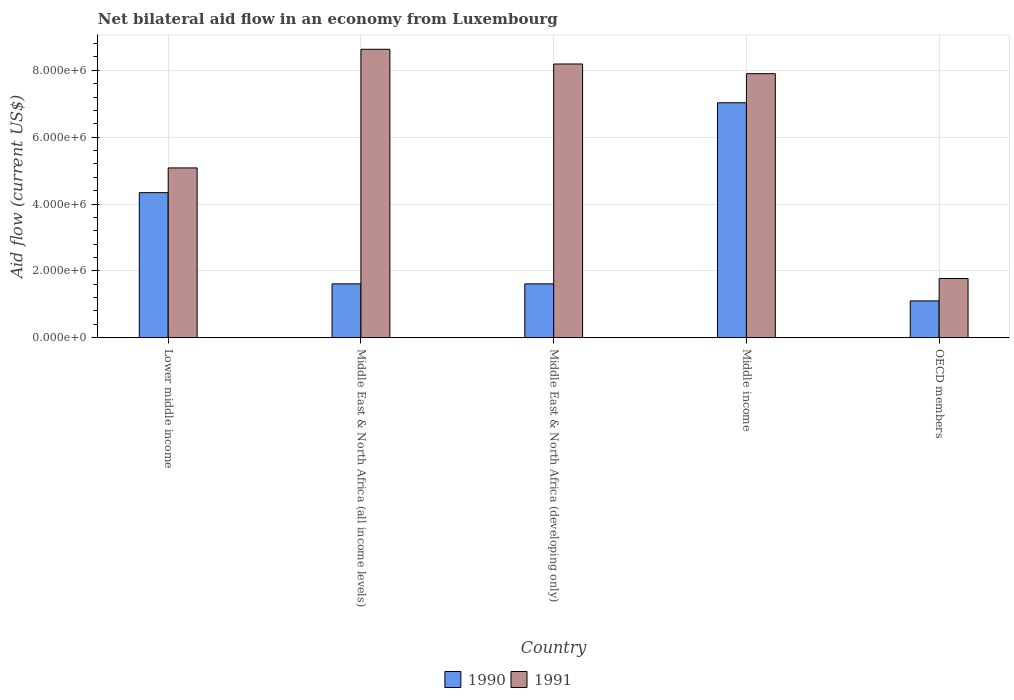Are the number of bars per tick equal to the number of legend labels?
Provide a short and direct response. Yes. How many bars are there on the 5th tick from the left?
Give a very brief answer. 2. In how many cases, is the number of bars for a given country not equal to the number of legend labels?
Ensure brevity in your answer.  0. What is the net bilateral aid flow in 1990 in Lower middle income?
Your answer should be compact. 4.34e+06. Across all countries, what is the maximum net bilateral aid flow in 1990?
Offer a very short reply. 7.03e+06. Across all countries, what is the minimum net bilateral aid flow in 1991?
Provide a succinct answer. 1.77e+06. In which country was the net bilateral aid flow in 1990 maximum?
Give a very brief answer. Middle income. What is the total net bilateral aid flow in 1991 in the graph?
Your response must be concise. 3.16e+07. What is the difference between the net bilateral aid flow in 1991 in Middle East & North Africa (developing only) and the net bilateral aid flow in 1990 in Lower middle income?
Your answer should be very brief. 3.85e+06. What is the average net bilateral aid flow in 1991 per country?
Provide a succinct answer. 6.31e+06. What is the difference between the net bilateral aid flow of/in 1990 and net bilateral aid flow of/in 1991 in OECD members?
Ensure brevity in your answer.  -6.70e+05. What is the ratio of the net bilateral aid flow in 1990 in Lower middle income to that in Middle income?
Offer a terse response. 0.62. Is the difference between the net bilateral aid flow in 1990 in Middle East & North Africa (all income levels) and Middle East & North Africa (developing only) greater than the difference between the net bilateral aid flow in 1991 in Middle East & North Africa (all income levels) and Middle East & North Africa (developing only)?
Offer a terse response. No. What is the difference between the highest and the second highest net bilateral aid flow in 1991?
Give a very brief answer. 4.40e+05. What is the difference between the highest and the lowest net bilateral aid flow in 1990?
Provide a succinct answer. 5.93e+06. In how many countries, is the net bilateral aid flow in 1990 greater than the average net bilateral aid flow in 1990 taken over all countries?
Ensure brevity in your answer.  2. What does the 2nd bar from the left in Middle East & North Africa (all income levels) represents?
Keep it short and to the point. 1991. How many bars are there?
Offer a very short reply. 10. Are all the bars in the graph horizontal?
Offer a very short reply. No. What is the difference between two consecutive major ticks on the Y-axis?
Give a very brief answer. 2.00e+06. Where does the legend appear in the graph?
Keep it short and to the point. Bottom center. How are the legend labels stacked?
Give a very brief answer. Horizontal. What is the title of the graph?
Keep it short and to the point. Net bilateral aid flow in an economy from Luxembourg. Does "1978" appear as one of the legend labels in the graph?
Offer a terse response. No. What is the label or title of the X-axis?
Your response must be concise. Country. What is the Aid flow (current US$) of 1990 in Lower middle income?
Make the answer very short. 4.34e+06. What is the Aid flow (current US$) in 1991 in Lower middle income?
Your answer should be compact. 5.08e+06. What is the Aid flow (current US$) of 1990 in Middle East & North Africa (all income levels)?
Your response must be concise. 1.61e+06. What is the Aid flow (current US$) in 1991 in Middle East & North Africa (all income levels)?
Provide a short and direct response. 8.63e+06. What is the Aid flow (current US$) of 1990 in Middle East & North Africa (developing only)?
Make the answer very short. 1.61e+06. What is the Aid flow (current US$) in 1991 in Middle East & North Africa (developing only)?
Your answer should be very brief. 8.19e+06. What is the Aid flow (current US$) in 1990 in Middle income?
Give a very brief answer. 7.03e+06. What is the Aid flow (current US$) of 1991 in Middle income?
Offer a very short reply. 7.90e+06. What is the Aid flow (current US$) in 1990 in OECD members?
Provide a short and direct response. 1.10e+06. What is the Aid flow (current US$) of 1991 in OECD members?
Provide a short and direct response. 1.77e+06. Across all countries, what is the maximum Aid flow (current US$) of 1990?
Give a very brief answer. 7.03e+06. Across all countries, what is the maximum Aid flow (current US$) of 1991?
Ensure brevity in your answer.  8.63e+06. Across all countries, what is the minimum Aid flow (current US$) in 1990?
Your response must be concise. 1.10e+06. Across all countries, what is the minimum Aid flow (current US$) of 1991?
Make the answer very short. 1.77e+06. What is the total Aid flow (current US$) of 1990 in the graph?
Your response must be concise. 1.57e+07. What is the total Aid flow (current US$) of 1991 in the graph?
Ensure brevity in your answer.  3.16e+07. What is the difference between the Aid flow (current US$) of 1990 in Lower middle income and that in Middle East & North Africa (all income levels)?
Ensure brevity in your answer.  2.73e+06. What is the difference between the Aid flow (current US$) of 1991 in Lower middle income and that in Middle East & North Africa (all income levels)?
Provide a succinct answer. -3.55e+06. What is the difference between the Aid flow (current US$) of 1990 in Lower middle income and that in Middle East & North Africa (developing only)?
Provide a short and direct response. 2.73e+06. What is the difference between the Aid flow (current US$) of 1991 in Lower middle income and that in Middle East & North Africa (developing only)?
Your answer should be compact. -3.11e+06. What is the difference between the Aid flow (current US$) of 1990 in Lower middle income and that in Middle income?
Your answer should be compact. -2.69e+06. What is the difference between the Aid flow (current US$) of 1991 in Lower middle income and that in Middle income?
Your response must be concise. -2.82e+06. What is the difference between the Aid flow (current US$) of 1990 in Lower middle income and that in OECD members?
Provide a succinct answer. 3.24e+06. What is the difference between the Aid flow (current US$) in 1991 in Lower middle income and that in OECD members?
Your response must be concise. 3.31e+06. What is the difference between the Aid flow (current US$) in 1990 in Middle East & North Africa (all income levels) and that in Middle income?
Provide a short and direct response. -5.42e+06. What is the difference between the Aid flow (current US$) in 1991 in Middle East & North Africa (all income levels) and that in Middle income?
Your answer should be very brief. 7.30e+05. What is the difference between the Aid flow (current US$) of 1990 in Middle East & North Africa (all income levels) and that in OECD members?
Provide a short and direct response. 5.10e+05. What is the difference between the Aid flow (current US$) of 1991 in Middle East & North Africa (all income levels) and that in OECD members?
Give a very brief answer. 6.86e+06. What is the difference between the Aid flow (current US$) of 1990 in Middle East & North Africa (developing only) and that in Middle income?
Make the answer very short. -5.42e+06. What is the difference between the Aid flow (current US$) of 1990 in Middle East & North Africa (developing only) and that in OECD members?
Offer a terse response. 5.10e+05. What is the difference between the Aid flow (current US$) of 1991 in Middle East & North Africa (developing only) and that in OECD members?
Provide a succinct answer. 6.42e+06. What is the difference between the Aid flow (current US$) of 1990 in Middle income and that in OECD members?
Give a very brief answer. 5.93e+06. What is the difference between the Aid flow (current US$) in 1991 in Middle income and that in OECD members?
Your answer should be compact. 6.13e+06. What is the difference between the Aid flow (current US$) of 1990 in Lower middle income and the Aid flow (current US$) of 1991 in Middle East & North Africa (all income levels)?
Offer a very short reply. -4.29e+06. What is the difference between the Aid flow (current US$) in 1990 in Lower middle income and the Aid flow (current US$) in 1991 in Middle East & North Africa (developing only)?
Make the answer very short. -3.85e+06. What is the difference between the Aid flow (current US$) of 1990 in Lower middle income and the Aid flow (current US$) of 1991 in Middle income?
Ensure brevity in your answer.  -3.56e+06. What is the difference between the Aid flow (current US$) of 1990 in Lower middle income and the Aid flow (current US$) of 1991 in OECD members?
Offer a terse response. 2.57e+06. What is the difference between the Aid flow (current US$) in 1990 in Middle East & North Africa (all income levels) and the Aid flow (current US$) in 1991 in Middle East & North Africa (developing only)?
Make the answer very short. -6.58e+06. What is the difference between the Aid flow (current US$) in 1990 in Middle East & North Africa (all income levels) and the Aid flow (current US$) in 1991 in Middle income?
Provide a short and direct response. -6.29e+06. What is the difference between the Aid flow (current US$) of 1990 in Middle East & North Africa (all income levels) and the Aid flow (current US$) of 1991 in OECD members?
Your answer should be compact. -1.60e+05. What is the difference between the Aid flow (current US$) of 1990 in Middle East & North Africa (developing only) and the Aid flow (current US$) of 1991 in Middle income?
Make the answer very short. -6.29e+06. What is the difference between the Aid flow (current US$) of 1990 in Middle East & North Africa (developing only) and the Aid flow (current US$) of 1991 in OECD members?
Keep it short and to the point. -1.60e+05. What is the difference between the Aid flow (current US$) of 1990 in Middle income and the Aid flow (current US$) of 1991 in OECD members?
Offer a very short reply. 5.26e+06. What is the average Aid flow (current US$) of 1990 per country?
Give a very brief answer. 3.14e+06. What is the average Aid flow (current US$) of 1991 per country?
Keep it short and to the point. 6.31e+06. What is the difference between the Aid flow (current US$) in 1990 and Aid flow (current US$) in 1991 in Lower middle income?
Keep it short and to the point. -7.40e+05. What is the difference between the Aid flow (current US$) of 1990 and Aid flow (current US$) of 1991 in Middle East & North Africa (all income levels)?
Ensure brevity in your answer.  -7.02e+06. What is the difference between the Aid flow (current US$) of 1990 and Aid flow (current US$) of 1991 in Middle East & North Africa (developing only)?
Keep it short and to the point. -6.58e+06. What is the difference between the Aid flow (current US$) in 1990 and Aid flow (current US$) in 1991 in Middle income?
Offer a very short reply. -8.70e+05. What is the difference between the Aid flow (current US$) in 1990 and Aid flow (current US$) in 1991 in OECD members?
Provide a short and direct response. -6.70e+05. What is the ratio of the Aid flow (current US$) in 1990 in Lower middle income to that in Middle East & North Africa (all income levels)?
Offer a very short reply. 2.7. What is the ratio of the Aid flow (current US$) of 1991 in Lower middle income to that in Middle East & North Africa (all income levels)?
Your answer should be very brief. 0.59. What is the ratio of the Aid flow (current US$) in 1990 in Lower middle income to that in Middle East & North Africa (developing only)?
Give a very brief answer. 2.7. What is the ratio of the Aid flow (current US$) of 1991 in Lower middle income to that in Middle East & North Africa (developing only)?
Your response must be concise. 0.62. What is the ratio of the Aid flow (current US$) of 1990 in Lower middle income to that in Middle income?
Make the answer very short. 0.62. What is the ratio of the Aid flow (current US$) of 1991 in Lower middle income to that in Middle income?
Offer a very short reply. 0.64. What is the ratio of the Aid flow (current US$) of 1990 in Lower middle income to that in OECD members?
Offer a very short reply. 3.95. What is the ratio of the Aid flow (current US$) of 1991 in Lower middle income to that in OECD members?
Offer a terse response. 2.87. What is the ratio of the Aid flow (current US$) of 1990 in Middle East & North Africa (all income levels) to that in Middle East & North Africa (developing only)?
Keep it short and to the point. 1. What is the ratio of the Aid flow (current US$) of 1991 in Middle East & North Africa (all income levels) to that in Middle East & North Africa (developing only)?
Give a very brief answer. 1.05. What is the ratio of the Aid flow (current US$) in 1990 in Middle East & North Africa (all income levels) to that in Middle income?
Ensure brevity in your answer.  0.23. What is the ratio of the Aid flow (current US$) in 1991 in Middle East & North Africa (all income levels) to that in Middle income?
Offer a very short reply. 1.09. What is the ratio of the Aid flow (current US$) of 1990 in Middle East & North Africa (all income levels) to that in OECD members?
Provide a short and direct response. 1.46. What is the ratio of the Aid flow (current US$) of 1991 in Middle East & North Africa (all income levels) to that in OECD members?
Provide a succinct answer. 4.88. What is the ratio of the Aid flow (current US$) of 1990 in Middle East & North Africa (developing only) to that in Middle income?
Make the answer very short. 0.23. What is the ratio of the Aid flow (current US$) of 1991 in Middle East & North Africa (developing only) to that in Middle income?
Keep it short and to the point. 1.04. What is the ratio of the Aid flow (current US$) in 1990 in Middle East & North Africa (developing only) to that in OECD members?
Your response must be concise. 1.46. What is the ratio of the Aid flow (current US$) of 1991 in Middle East & North Africa (developing only) to that in OECD members?
Ensure brevity in your answer.  4.63. What is the ratio of the Aid flow (current US$) of 1990 in Middle income to that in OECD members?
Provide a short and direct response. 6.39. What is the ratio of the Aid flow (current US$) of 1991 in Middle income to that in OECD members?
Provide a short and direct response. 4.46. What is the difference between the highest and the second highest Aid flow (current US$) of 1990?
Offer a terse response. 2.69e+06. What is the difference between the highest and the lowest Aid flow (current US$) in 1990?
Offer a terse response. 5.93e+06. What is the difference between the highest and the lowest Aid flow (current US$) of 1991?
Offer a very short reply. 6.86e+06. 